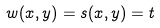<formula> <loc_0><loc_0><loc_500><loc_500>w ( x , y ) = s ( x , y ) = t</formula> 